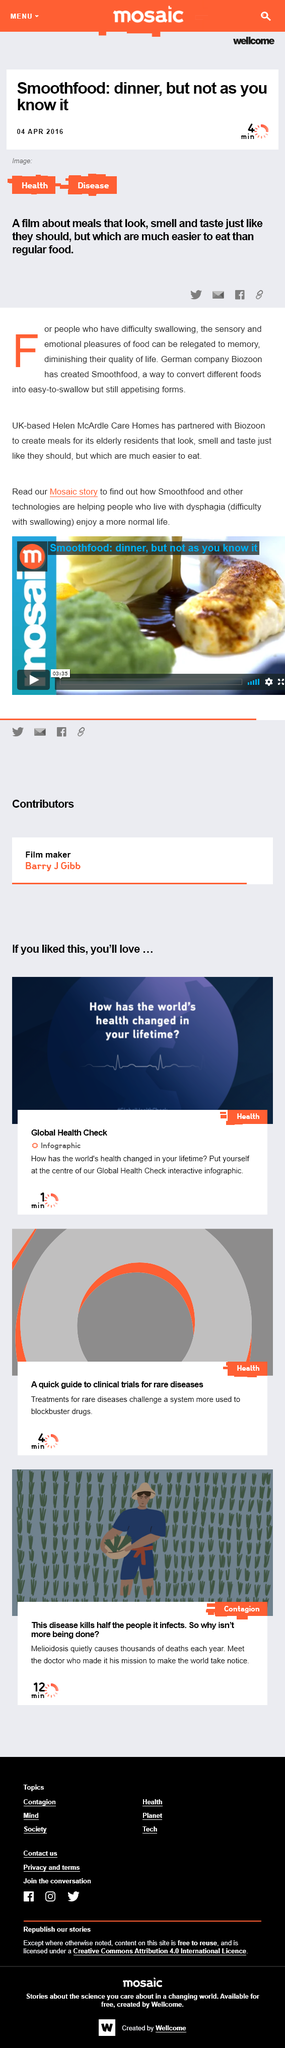Indicate a few pertinent items in this graphic. Helen McArdle Care Homes, a UK-based care home, has formed a partnership with Biozoon, a leading provider of digital solutions for the care industry. Biozoon, a German company, created Smoothfood. The film is about Smoothfood. 